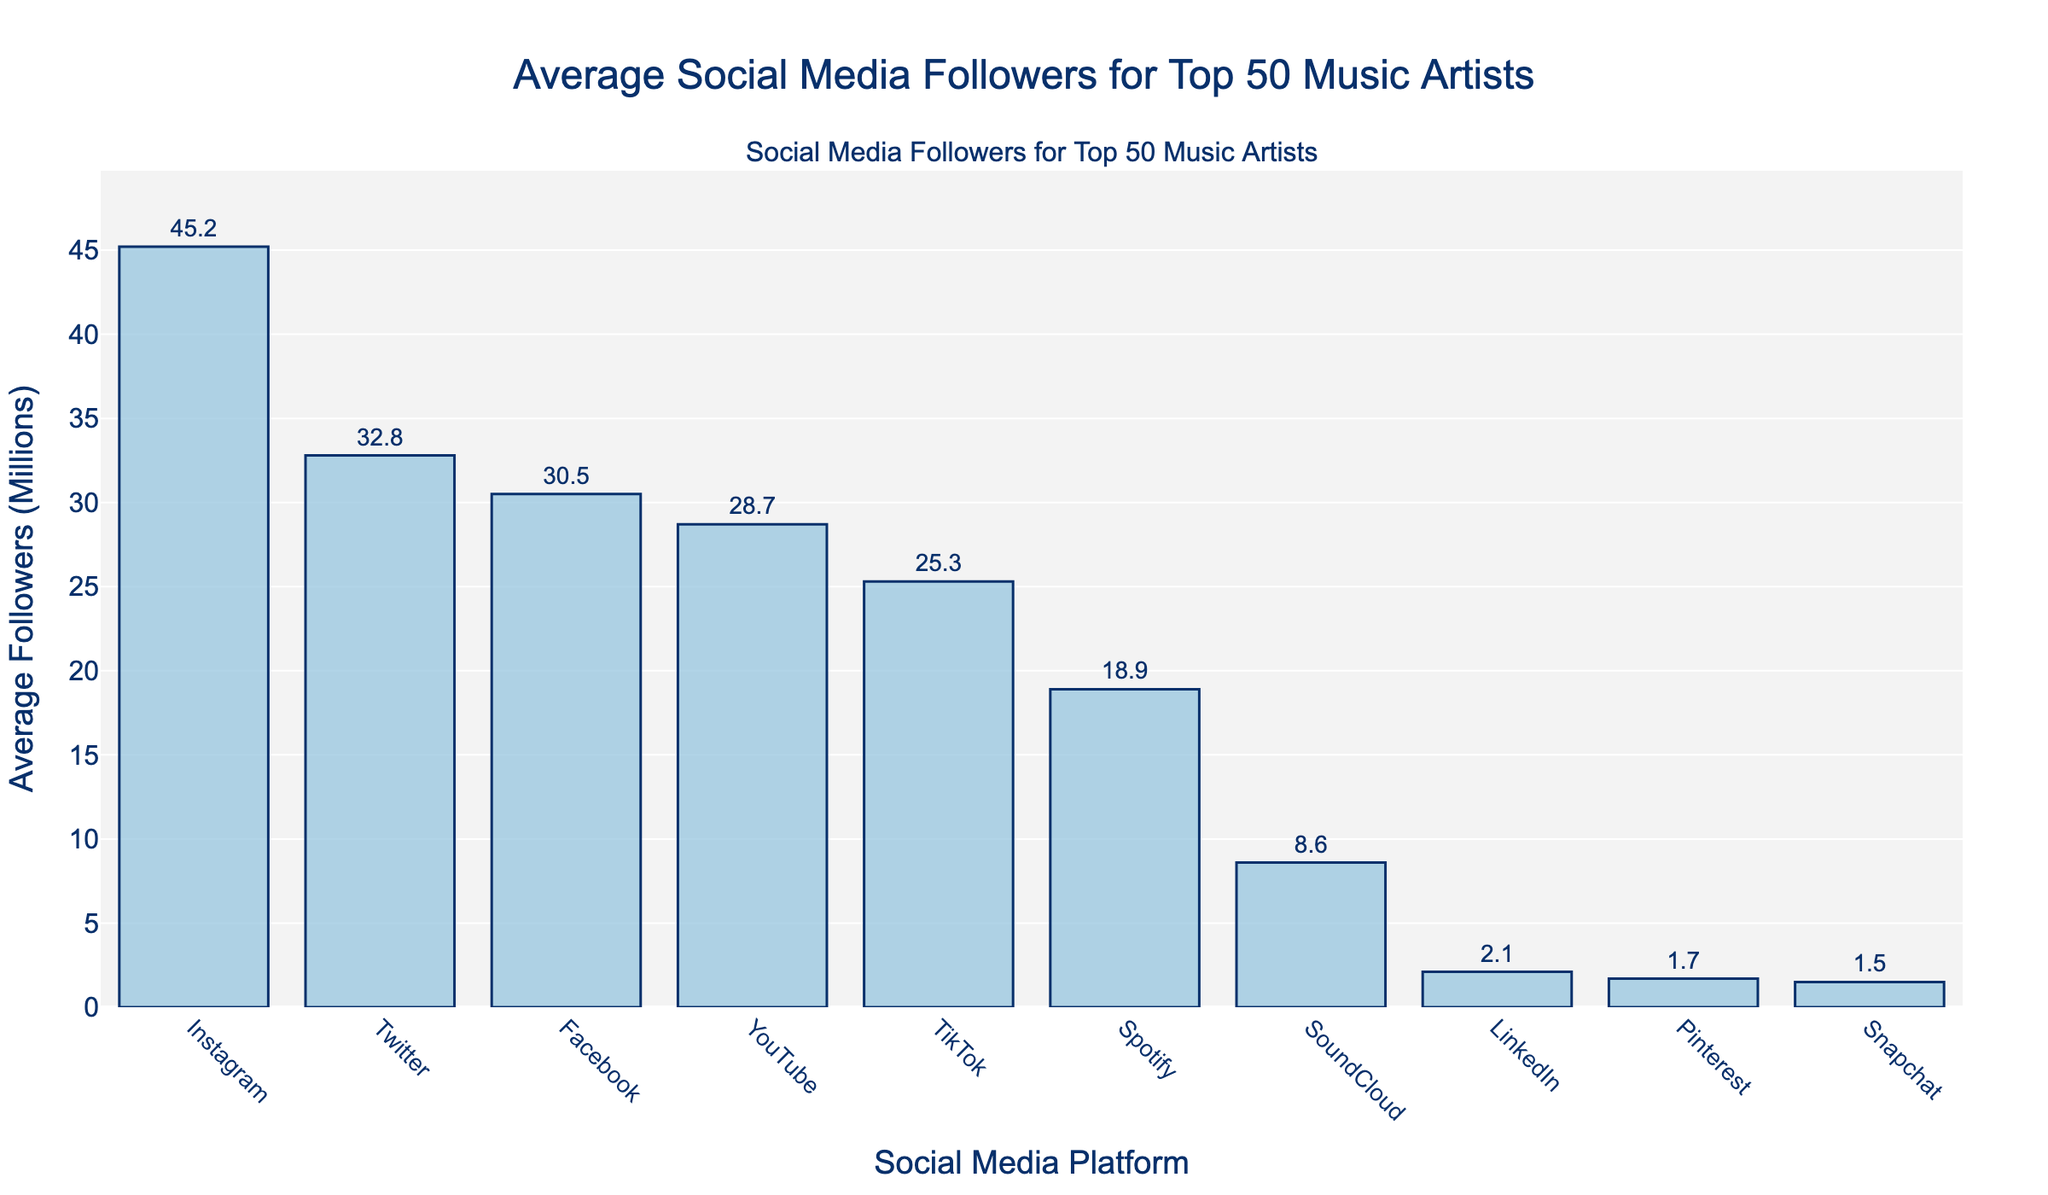Which platform has the highest average number of followers? By looking at the height of the bars, Instagram has the tallest bar, which indicates it has the highest average number of followers.
Answer: Instagram Which platform has the lowest average number of followers? By looking at the height of the bars, Snapchat has the shortest bar, which indicates it has the lowest average number of followers.
Answer: Snapchat How many platforms have an average number of followers greater than 30 million? By observing the bars and their corresponding values, the platforms with average followers above 30 million are Instagram, Twitter, and Facebook. Counting these gives three platforms.
Answer: 3 What is the combined average number of followers for Instagram and YouTube? The average number of followers for Instagram is 45.2 million and for YouTube is 28.7 million. Adding these together gives 45.2 + 28.7 = 73.9 million.
Answer: 73.9 million How much more average followers does TikTok have compared to SoundCloud? TikTok has an average of 25.3 million followers and SoundCloud has 8.6 million. The difference is 25.3 - 8.6 = 16.7 million followers.
Answer: 16.7 million What is the average number of followers across all platforms? Sum all average follower counts: 45.2 + 32.8 + 30.5 + 28.7 + 25.3 + 18.9 + 8.6 + 2.1 + 1.7 + 1.5 = 195.3. Divide by the number of platforms (10). So, the average is 195.3 / 10 = 19.53 million.
Answer: 19.53 million Are there more platforms with average followers greater than 20 million or less than 20 million? Platforms greater than 20 million: Instagram, Twitter, Facebook, YouTube, TikTok (5 platforms). Platforms less than 20 million: Spotify, SoundCloud, LinkedIn, Pinterest, Snapchat (5 platforms). Thus, they are equal.
Answer: Equal What is the median average number of followers? Ordering the follower counts: 1.5, 1.7, 2.1, 8.6, 18.9, 25.3, 28.7, 30.5, 32.8, 45.2. The median is the average of the 5th and 6th values (18.9 and 25.3). So, (18.9 + 25.3) / 2 = 22.1 million.
Answer: 22.1 million What's the difference in average followers between Facebook and LinkedIn? Facebook has 30.5 million and LinkedIn has 2.1 million. The difference is 30.5 - 2.1 = 28.4 million.
Answer: 28.4 million Which platform has more followers: Instagram and TikTok combined, or YouTube and Twitter combined? Instagram and TikTok combined: 45.2 + 25.3 = 70.5 million. YouTube and Twitter combined: 28.7 + 32.8 = 61.5 million. So, Instagram and TikTok combined have more followers.
Answer: Instagram and TikTok 